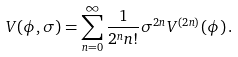<formula> <loc_0><loc_0><loc_500><loc_500>V ( \phi , \sigma ) = \sum _ { n = 0 } ^ { \infty } \frac { 1 } { 2 ^ { n } n ! } \sigma ^ { 2 n } V ^ { ( 2 n ) } ( \phi ) \, .</formula> 